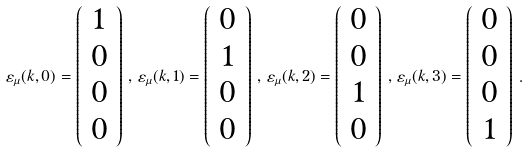Convert formula to latex. <formula><loc_0><loc_0><loc_500><loc_500>\varepsilon _ { \mu } ( k , 0 ) = \left ( \begin{array} { c } 1 \\ 0 \\ 0 \\ 0 \end{array} \right ) \, , \, \varepsilon _ { \mu } ( k , 1 ) = \left ( \begin{array} { c } 0 \\ 1 \\ 0 \\ 0 \end{array} \right ) \, , \, \varepsilon _ { \mu } ( k , 2 ) = \left ( \begin{array} { c } 0 \\ 0 \\ 1 \\ 0 \end{array} \right ) \, , \, \varepsilon _ { \mu } ( k , 3 ) = \left ( \begin{array} { c } 0 \\ 0 \\ 0 \\ 1 \end{array} \right ) \, .</formula> 